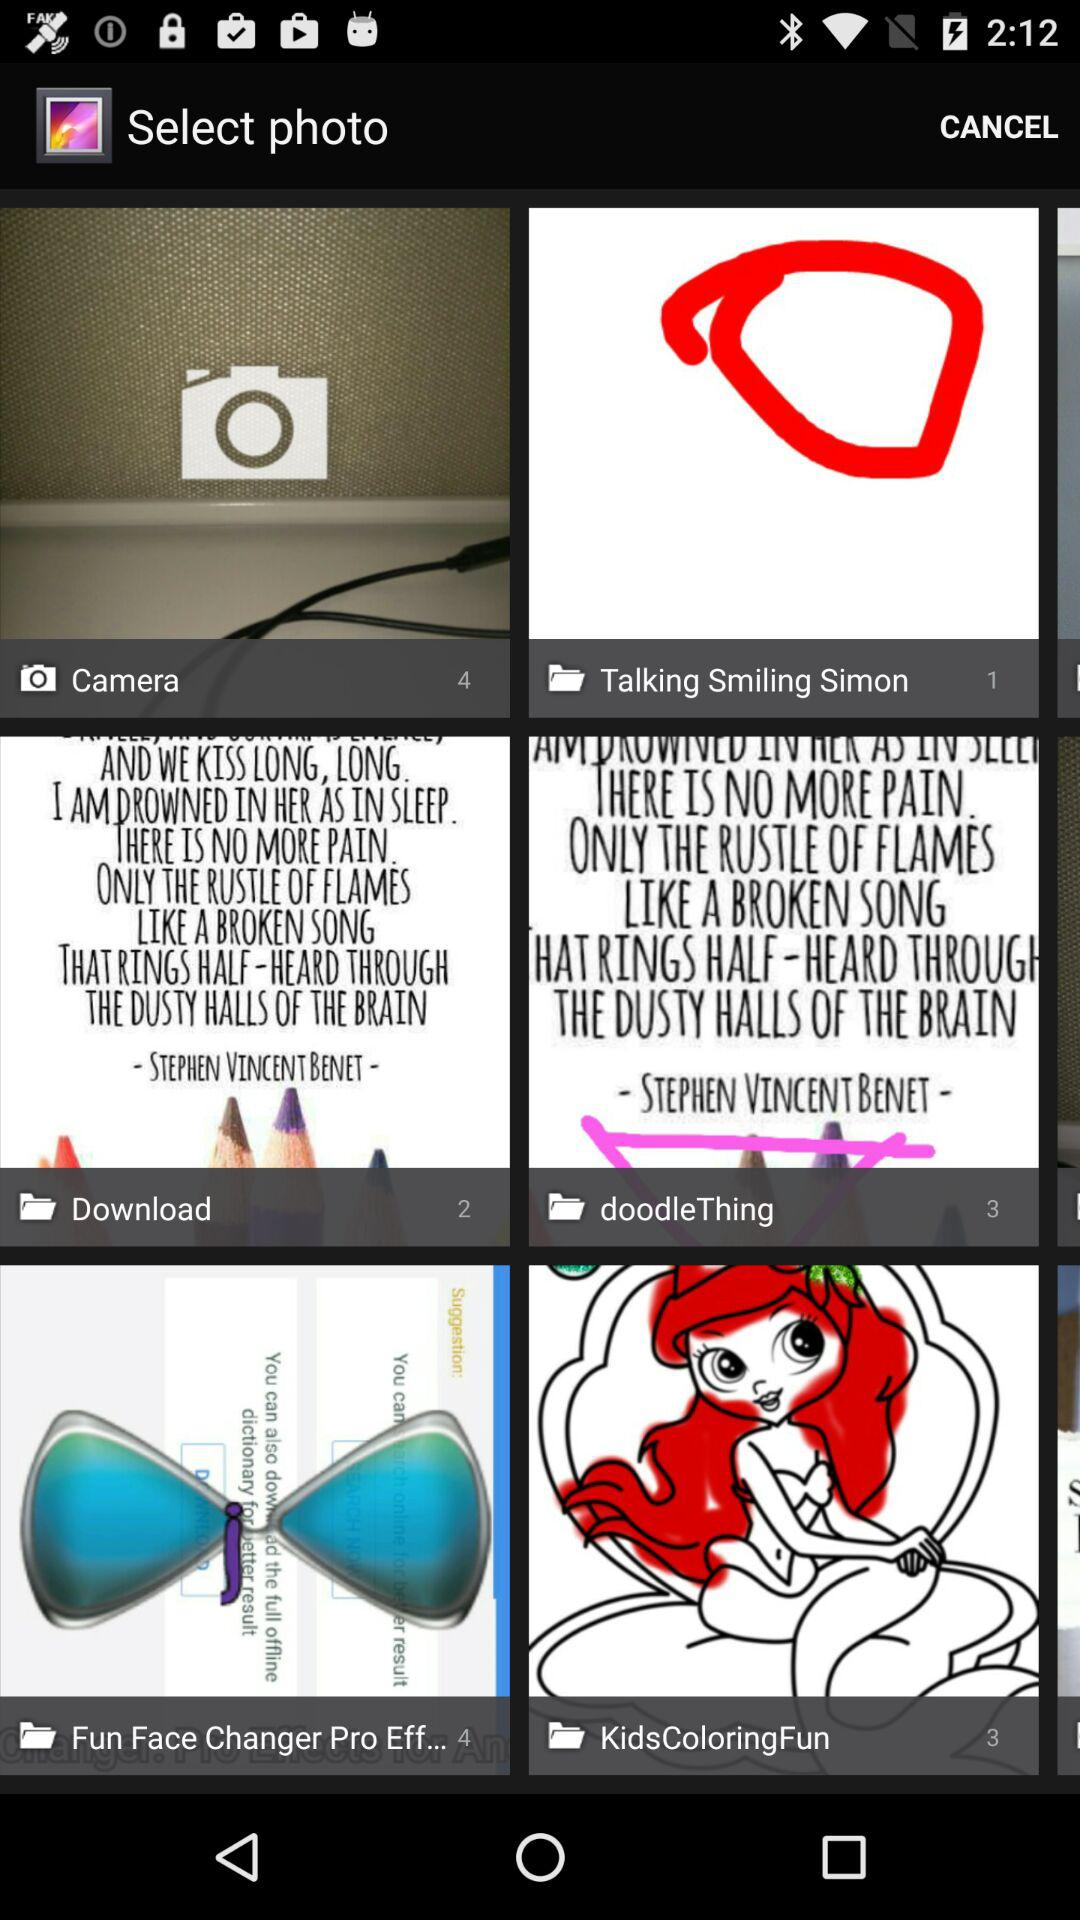How many photos are stored in the "Fun Face Changer Pro Eff..."? There are 4 photos stored in the "Fun Face Changer Pro Eff...". 